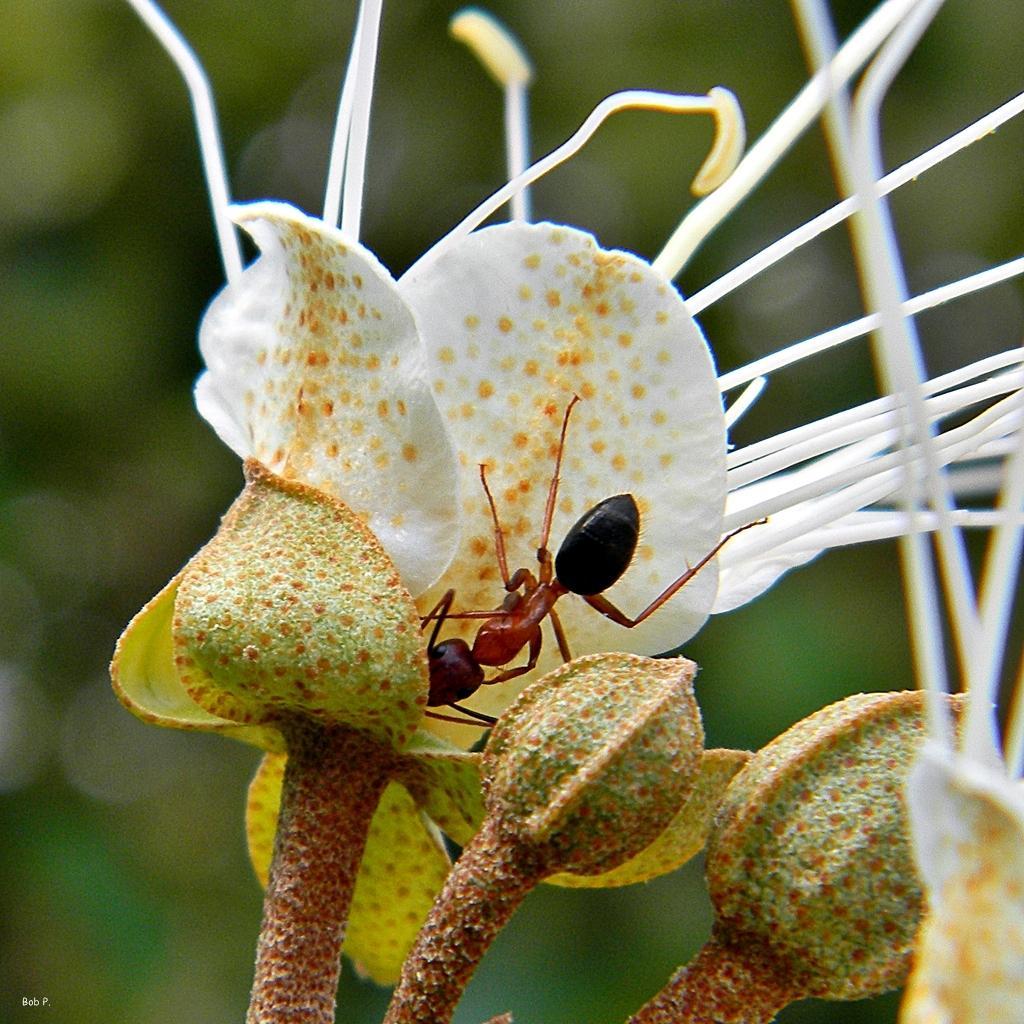Can you describe this image briefly? In this image, we can see an ant on the flower. In the background, image is blurred. 